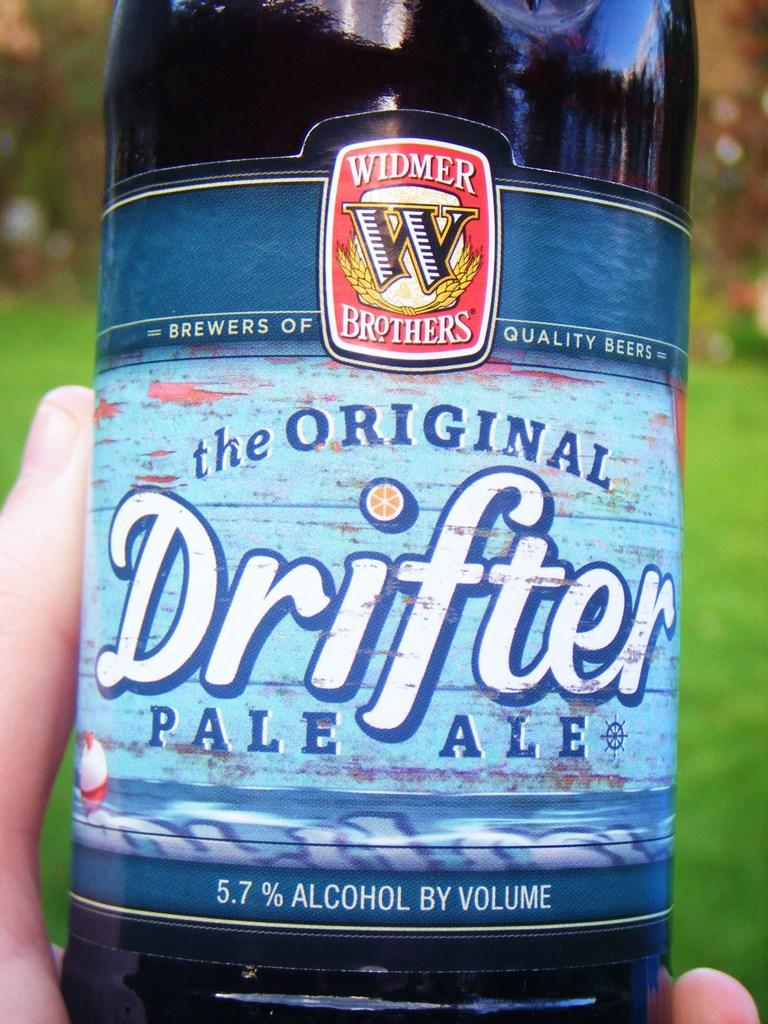<image>
Write a terse but informative summary of the picture. The Original Drifter Pale Ale is being held in front of a grassy area 